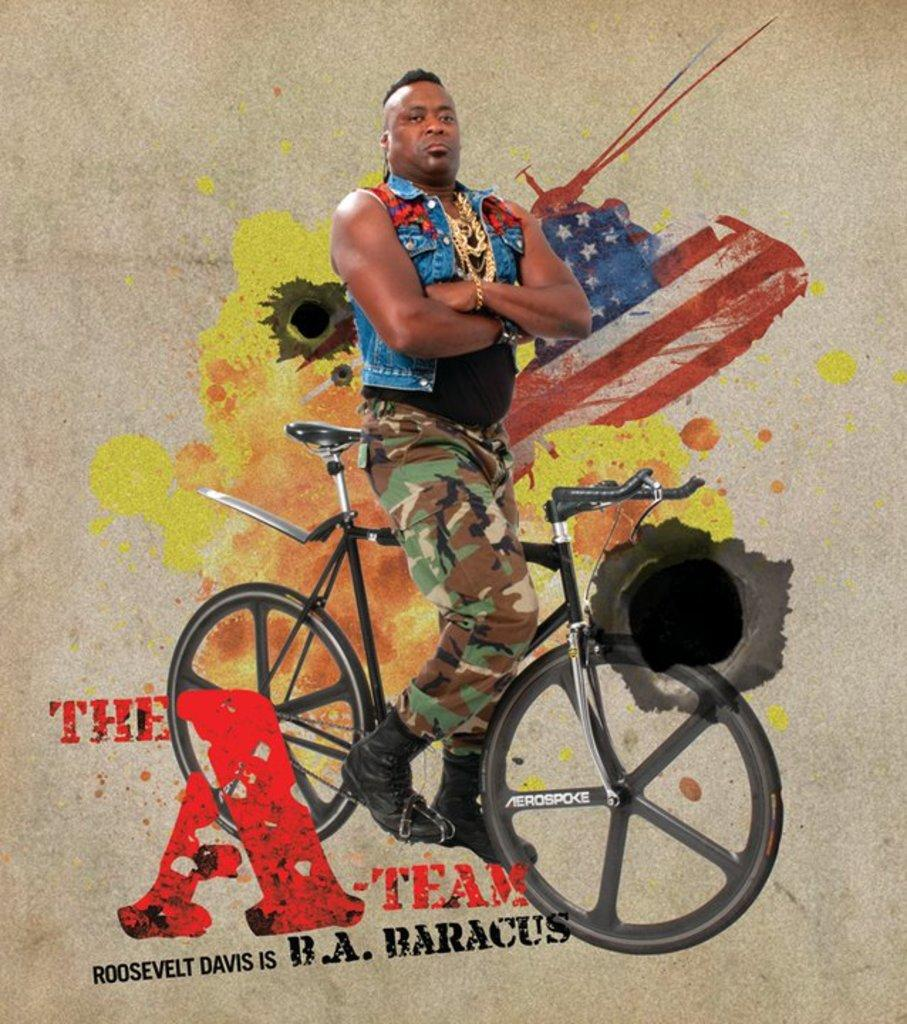Who is the main subject in the image? There is a man in the image. What object is also present in the image? There is a cycle in the image. What type of artwork is the image? The image is a painting. What type of trousers is the governor wearing in the image? There is no governor present in the image, and therefore no trousers to describe. 